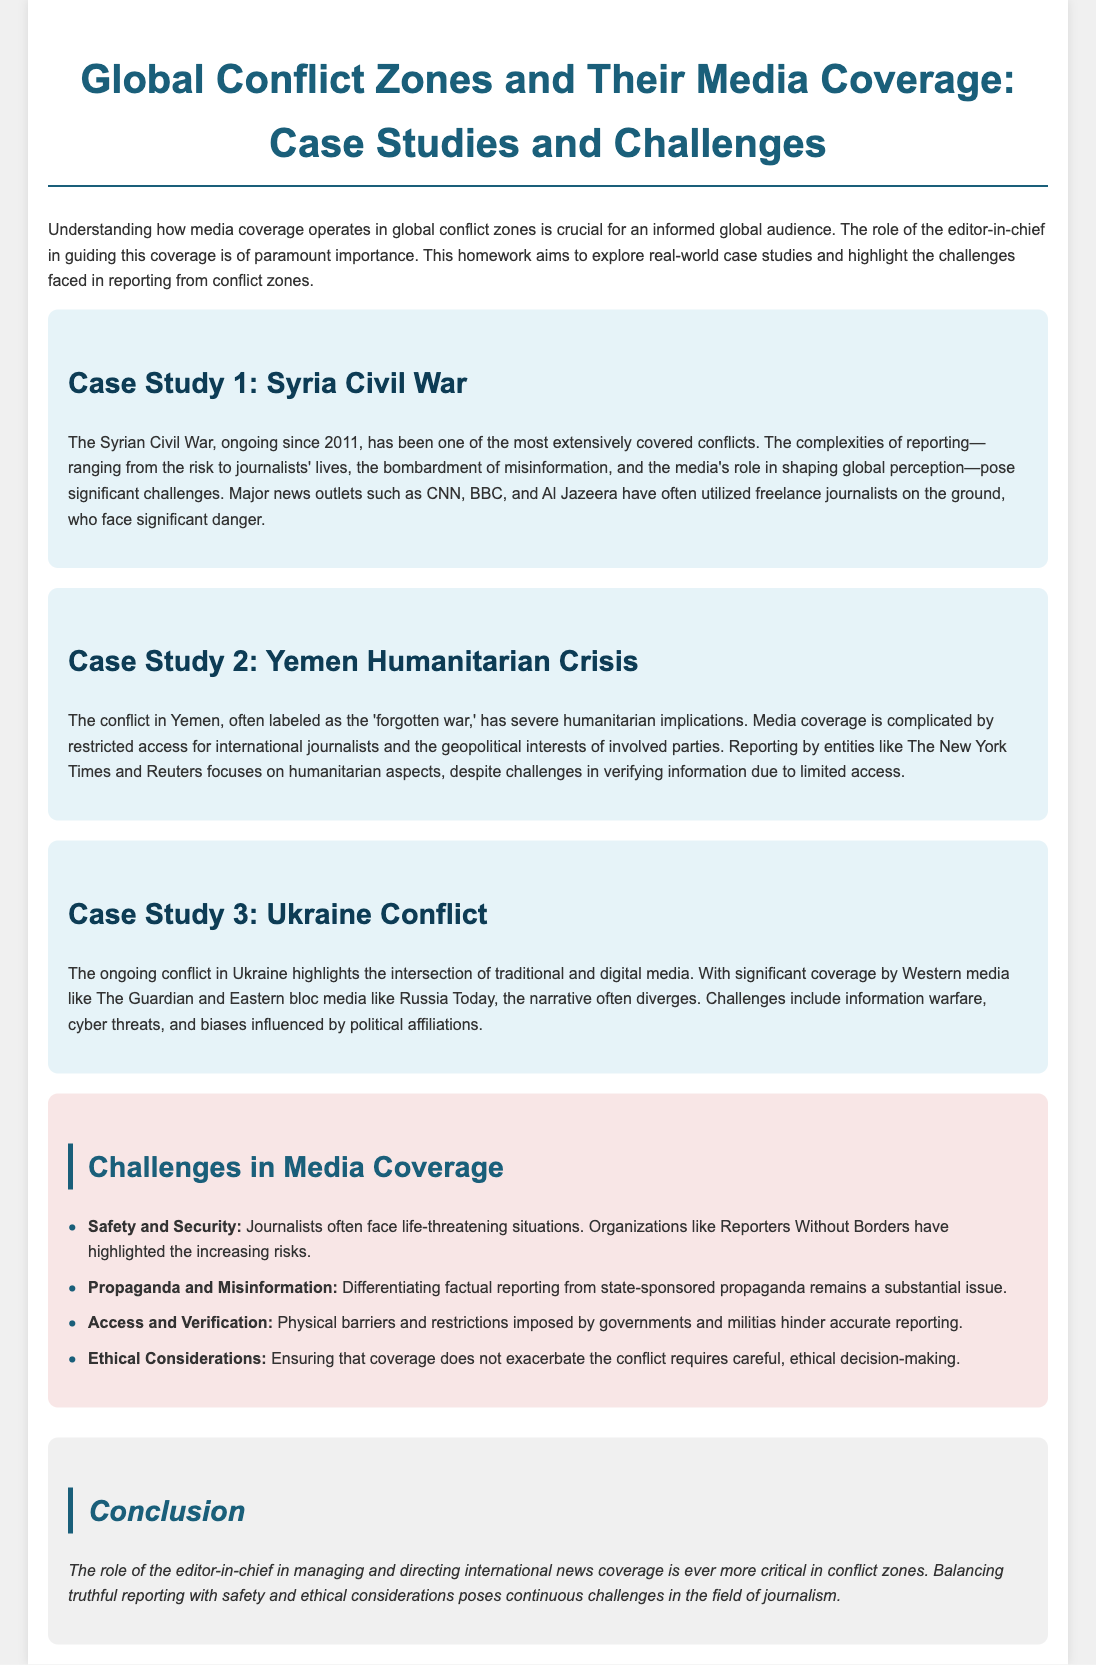What is the title of the document? The title of the document is displayed prominently at the top, indicating its main focus.
Answer: Global Conflict Zones and Their Media Coverage: Case Studies and Challenges How many case studies are presented in the document? The document explicitly lists three case studies under the case study section.
Answer: 3 What is the main focus of the first case study? The first case study covers the ongoing conflict and challenges in reporting from Syria, highlighting significant aspects.
Answer: Syria Civil War Which organization emphasizes the safety risks faced by journalists? The document mentions an organization that specifically addresses the safety of journalists, highlighting their concerns.
Answer: Reporters Without Borders What is one challenge mentioned regarding media coverage in Yemen? The document outlines challenges in accessing information in Yemen due to certain conditions and geopolitical interests.
Answer: Restricted access What is one ethical consideration mentioned in the challenges section? The challenges section discusses the need for ethical decision-making in covering conflicts without worsening situations.
Answer: Ethical considerations Which two major media outlets are mentioned in the discussion of the Ukraine conflict? The document points out notable media outlets that cover the Ukraine conflict, reflecting a wider coverage spectrum.
Answer: The Guardian and Russia Today What does the conclusion state about the role of the editor-in-chief? The conclusion highlights the significance of the editor-in-chief's role in international news coverage, particularly in conflict zones.
Answer: Critical What humanitarian aspect is emphasized in the case study of Yemen? The case study focuses on a significant humanitarian crisis caused by the ongoing conflict in Yemen.
Answer: Humanitarian implications 